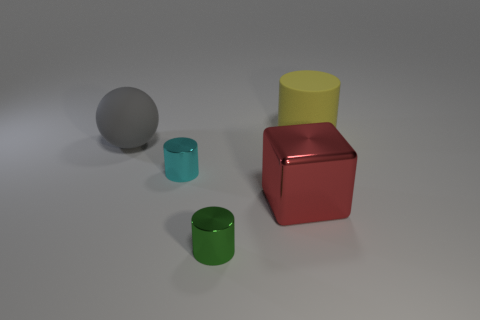What material is the gray ball that is the same size as the red block?
Provide a succinct answer. Rubber. Are there any cyan metallic cylinders that have the same size as the green metal object?
Offer a terse response. Yes. Do the object behind the gray sphere and the gray rubber thing have the same size?
Your answer should be very brief. Yes. The big thing that is both behind the red block and on the right side of the big ball has what shape?
Provide a succinct answer. Cylinder. Are there more tiny cyan metal things on the right side of the large gray ball than tiny green blocks?
Your answer should be compact. Yes. What size is the red block that is made of the same material as the tiny cyan thing?
Provide a short and direct response. Large. What number of metallic things are the same color as the metallic cube?
Provide a succinct answer. 0. Are there an equal number of metal cylinders that are behind the green shiny cylinder and cylinders that are behind the ball?
Make the answer very short. Yes. There is a big rubber object that is right of the green metallic object; what is its color?
Your answer should be compact. Yellow. Is the number of large yellow matte objects that are behind the large yellow cylinder the same as the number of tiny blue rubber things?
Offer a very short reply. Yes. 